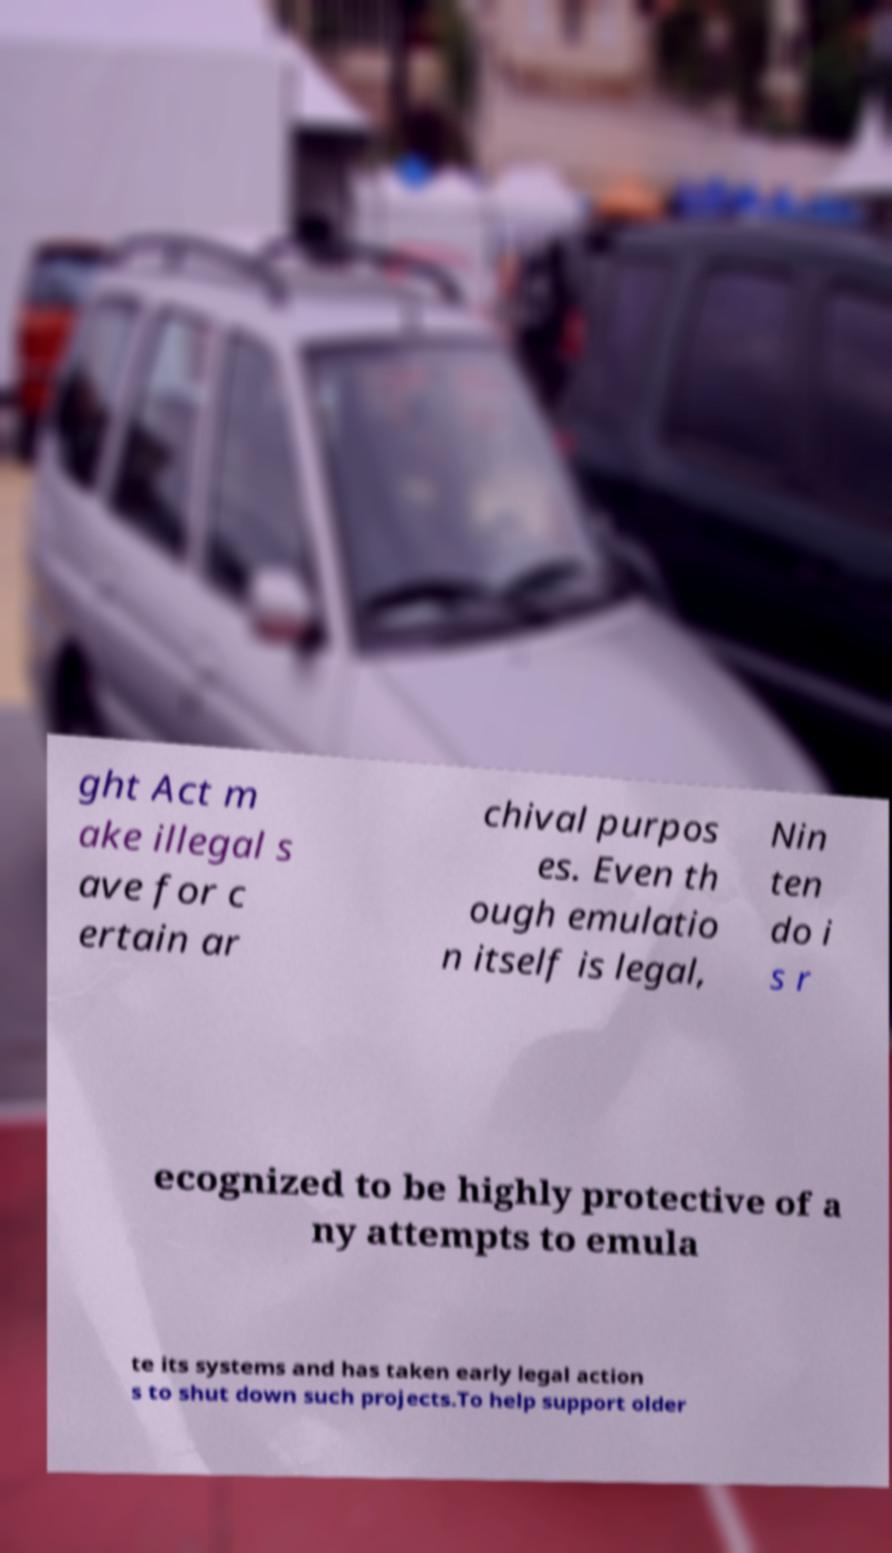Could you assist in decoding the text presented in this image and type it out clearly? ght Act m ake illegal s ave for c ertain ar chival purpos es. Even th ough emulatio n itself is legal, Nin ten do i s r ecognized to be highly protective of a ny attempts to emula te its systems and has taken early legal action s to shut down such projects.To help support older 